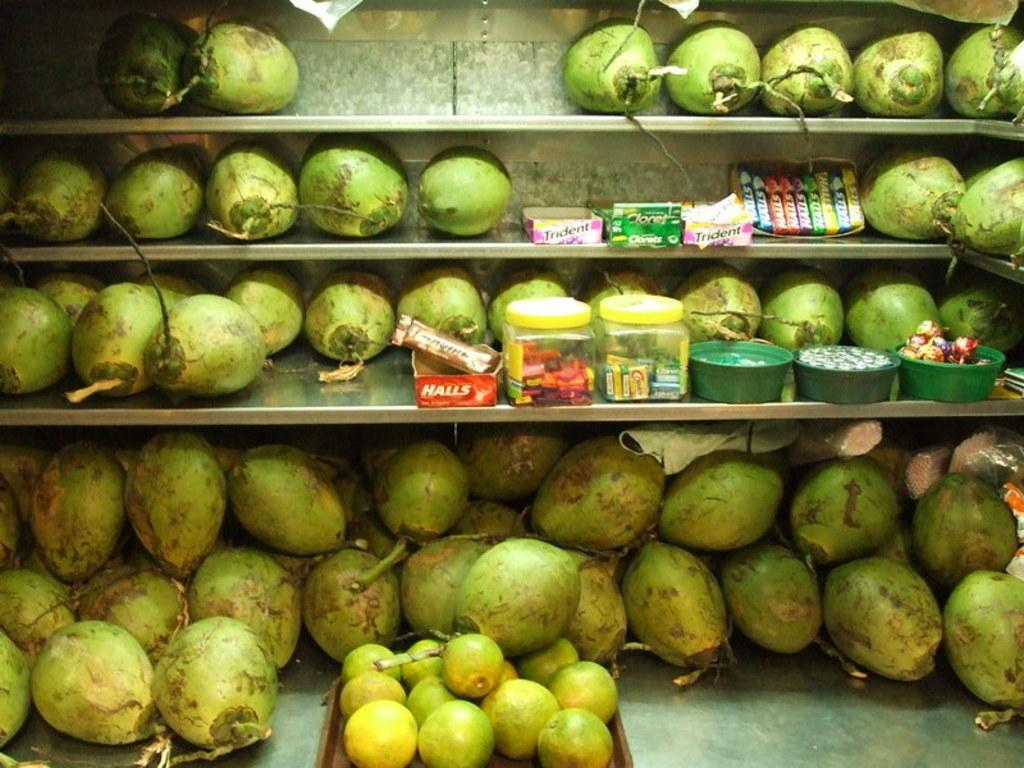What type of food items can be seen in the image? There are coconuts, fruits, candies, lollipops, and chocolates in the image. Can you describe the lollipops in the image? The lollipops are in a box in the image. What other types of sweets are present in the image? There are candies and chocolates in the image. What type of bead is used to decorate the coconuts in the image? There are no beads present in the image, and the coconuts are not decorated. How does the rake help in the preparation of the fruits in the image? There is no rake present in the image, and the fruits are not being prepared. 